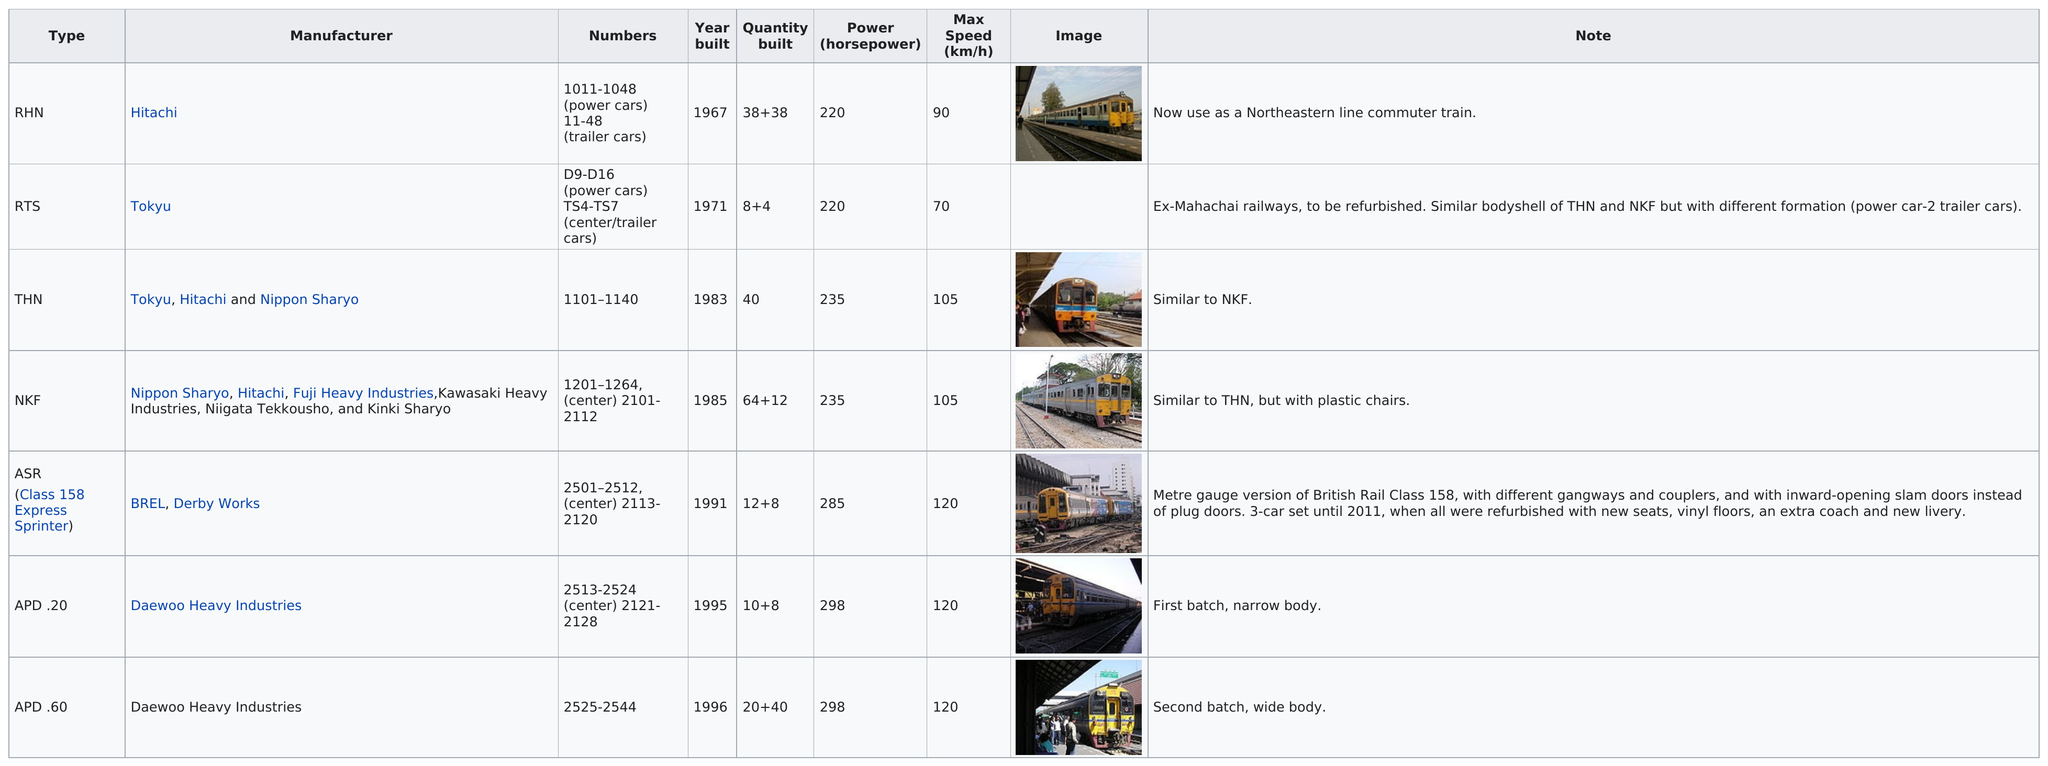Give some essential details in this illustration. Of the type with the lowest maximum speed, the RTS is the one that has the lowest maximum speed. Tokyo is listed as a manufacturer on this chart two times. Hitachi was the manufacturer of the first diesel multiple unit. The difference in horsepower between the NKF trains and the RTS trains is 15. There are five types of trains that have a top speed of more than 100 kilometers per hour. 